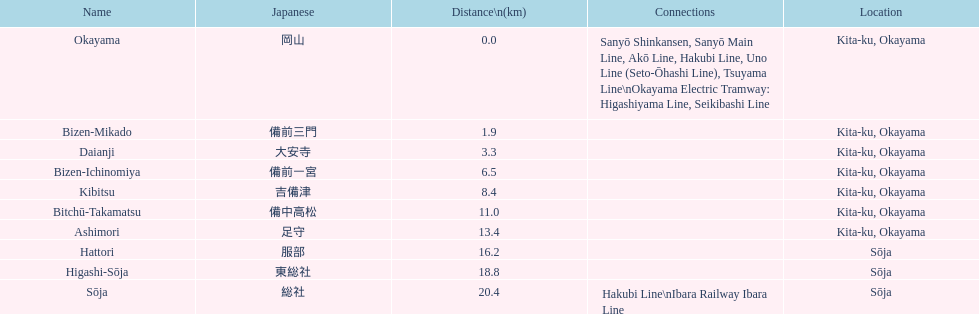Which spans a distance greater than 1 kilometer but lesser than 2 kilometers? Bizen-Mikado. 